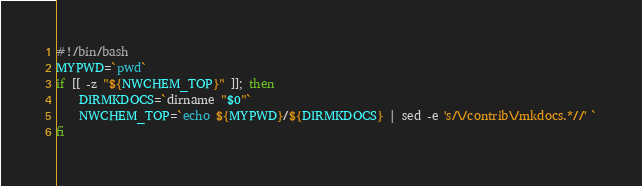Convert code to text. <code><loc_0><loc_0><loc_500><loc_500><_Bash_>#!/bin/bash
MYPWD=`pwd`
if [[ -z "${NWCHEM_TOP}" ]]; then
    DIRMKDOCS=`dirname "$0"`
    NWCHEM_TOP=`echo ${MYPWD}/${DIRMKDOCS} | sed -e 's/\/contrib\/mkdocs.*//' `
fi</code> 